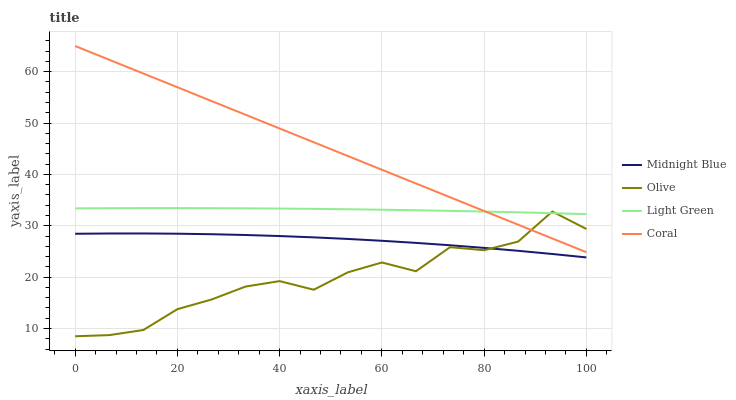Does Midnight Blue have the minimum area under the curve?
Answer yes or no. No. Does Midnight Blue have the maximum area under the curve?
Answer yes or no. No. Is Midnight Blue the smoothest?
Answer yes or no. No. Is Midnight Blue the roughest?
Answer yes or no. No. Does Coral have the lowest value?
Answer yes or no. No. Does Midnight Blue have the highest value?
Answer yes or no. No. Is Midnight Blue less than Light Green?
Answer yes or no. Yes. Is Coral greater than Midnight Blue?
Answer yes or no. Yes. Does Midnight Blue intersect Light Green?
Answer yes or no. No. 